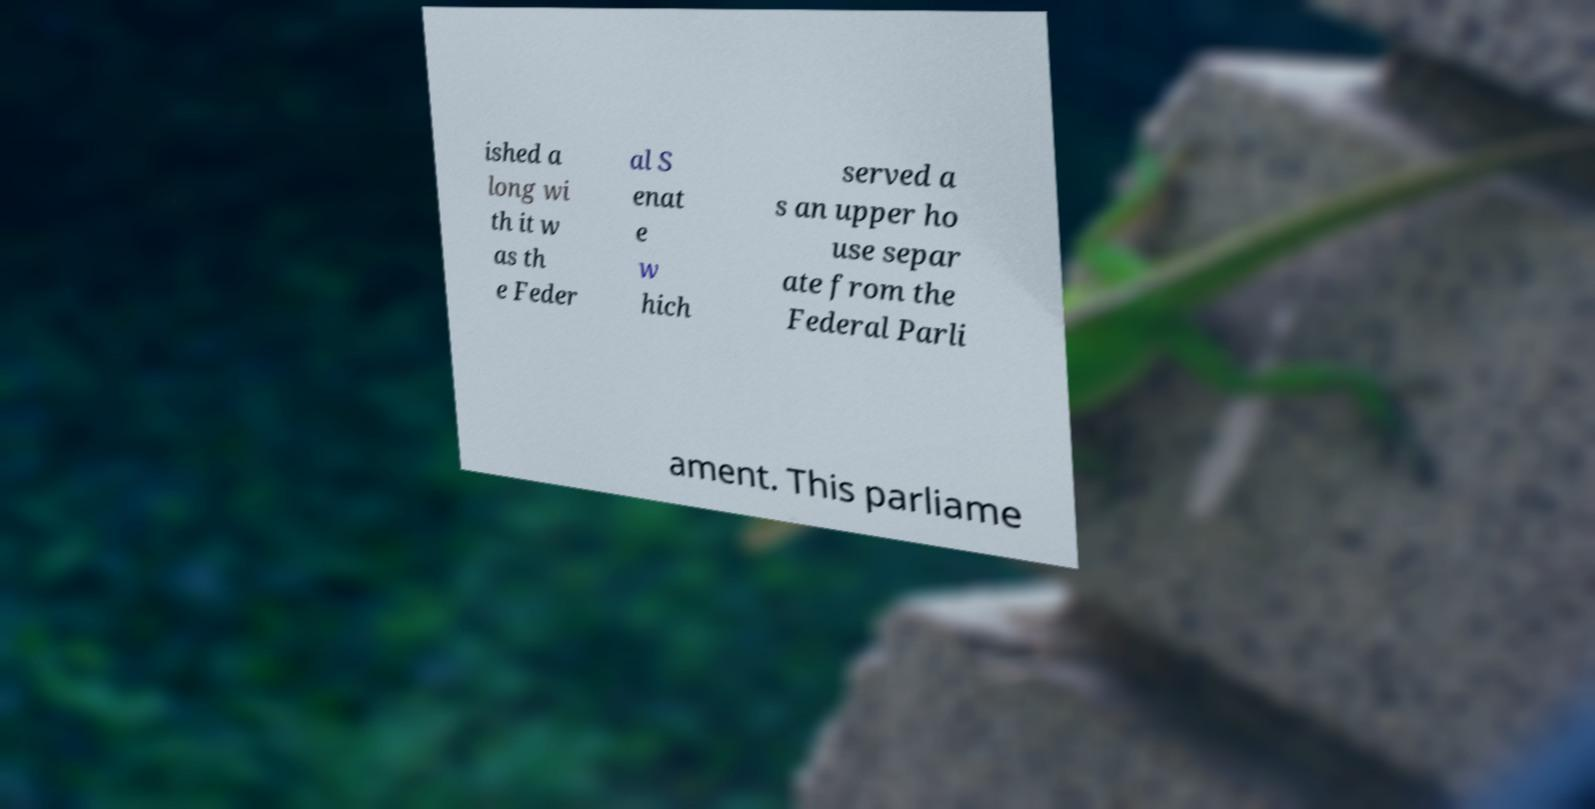For documentation purposes, I need the text within this image transcribed. Could you provide that? ished a long wi th it w as th e Feder al S enat e w hich served a s an upper ho use separ ate from the Federal Parli ament. This parliame 